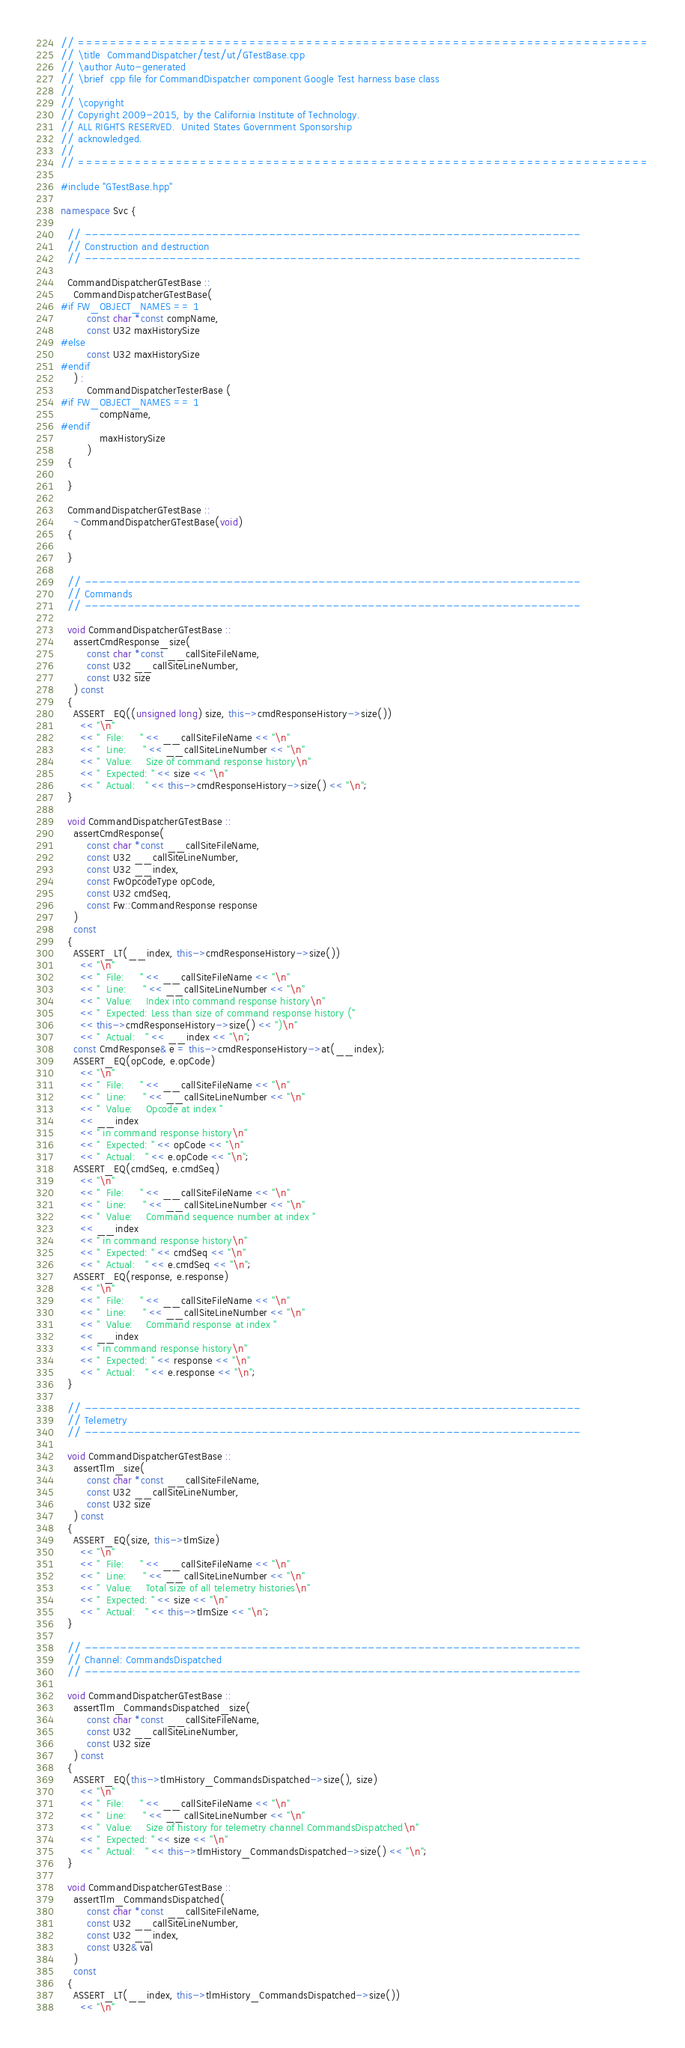<code> <loc_0><loc_0><loc_500><loc_500><_C++_>// ======================================================================
// \title  CommandDispatcher/test/ut/GTestBase.cpp
// \author Auto-generated
// \brief  cpp file for CommandDispatcher component Google Test harness base class
//
// \copyright
// Copyright 2009-2015, by the California Institute of Technology.
// ALL RIGHTS RESERVED.  United States Government Sponsorship
// acknowledged.
//
// ======================================================================

#include "GTestBase.hpp"

namespace Svc {

  // ----------------------------------------------------------------------
  // Construction and destruction
  // ----------------------------------------------------------------------

  CommandDispatcherGTestBase ::
    CommandDispatcherGTestBase(
#if FW_OBJECT_NAMES == 1
        const char *const compName,
        const U32 maxHistorySize
#else
        const U32 maxHistorySize
#endif
    ) :
        CommandDispatcherTesterBase (
#if FW_OBJECT_NAMES == 1
            compName,
#endif
            maxHistorySize
        )
  {

  }

  CommandDispatcherGTestBase ::
    ~CommandDispatcherGTestBase(void)
  {

  }

  // ----------------------------------------------------------------------
  // Commands
  // ----------------------------------------------------------------------

  void CommandDispatcherGTestBase ::
    assertCmdResponse_size(
        const char *const __callSiteFileName,
        const U32 __callSiteLineNumber,
        const U32 size
    ) const
  {
    ASSERT_EQ((unsigned long) size, this->cmdResponseHistory->size())
      << "\n"
      << "  File:     " << __callSiteFileName << "\n"
      << "  Line:     " << __callSiteLineNumber << "\n"
      << "  Value:    Size of command response history\n"
      << "  Expected: " << size << "\n"
      << "  Actual:   " << this->cmdResponseHistory->size() << "\n";
  }

  void CommandDispatcherGTestBase ::
    assertCmdResponse(
        const char *const __callSiteFileName,
        const U32 __callSiteLineNumber,
        const U32 __index,
        const FwOpcodeType opCode,
        const U32 cmdSeq,
        const Fw::CommandResponse response
    )
    const
  {
    ASSERT_LT(__index, this->cmdResponseHistory->size())
      << "\n"
      << "  File:     " << __callSiteFileName << "\n"
      << "  Line:     " << __callSiteLineNumber << "\n"
      << "  Value:    Index into command response history\n"
      << "  Expected: Less than size of command response history ("
      << this->cmdResponseHistory->size() << ")\n"
      << "  Actual:   " << __index << "\n";
    const CmdResponse& e = this->cmdResponseHistory->at(__index);
    ASSERT_EQ(opCode, e.opCode)
      << "\n"
      << "  File:     " << __callSiteFileName << "\n"
      << "  Line:     " << __callSiteLineNumber << "\n"
      << "  Value:    Opcode at index "
      << __index
      << " in command response history\n"
      << "  Expected: " << opCode << "\n"
      << "  Actual:   " << e.opCode << "\n";
    ASSERT_EQ(cmdSeq, e.cmdSeq)
      << "\n"
      << "  File:     " << __callSiteFileName << "\n"
      << "  Line:     " << __callSiteLineNumber << "\n"
      << "  Value:    Command sequence number at index "
      << __index
      << " in command response history\n"
      << "  Expected: " << cmdSeq << "\n"
      << "  Actual:   " << e.cmdSeq << "\n";
    ASSERT_EQ(response, e.response)
      << "\n"
      << "  File:     " << __callSiteFileName << "\n"
      << "  Line:     " << __callSiteLineNumber << "\n"
      << "  Value:    Command response at index "
      << __index
      << " in command response history\n"
      << "  Expected: " << response << "\n"
      << "  Actual:   " << e.response << "\n";
  }

  // ----------------------------------------------------------------------
  // Telemetry
  // ----------------------------------------------------------------------

  void CommandDispatcherGTestBase ::
    assertTlm_size(
        const char *const __callSiteFileName,
        const U32 __callSiteLineNumber,
        const U32 size
    ) const
  {
    ASSERT_EQ(size, this->tlmSize)
      << "\n"
      << "  File:     " << __callSiteFileName << "\n"
      << "  Line:     " << __callSiteLineNumber << "\n"
      << "  Value:    Total size of all telemetry histories\n"
      << "  Expected: " << size << "\n"
      << "  Actual:   " << this->tlmSize << "\n";
  }

  // ----------------------------------------------------------------------
  // Channel: CommandsDispatched
  // ----------------------------------------------------------------------

  void CommandDispatcherGTestBase ::
    assertTlm_CommandsDispatched_size(
        const char *const __callSiteFileName,
        const U32 __callSiteLineNumber,
        const U32 size
    ) const
  {
    ASSERT_EQ(this->tlmHistory_CommandsDispatched->size(), size)
      << "\n"
      << "  File:     " << __callSiteFileName << "\n"
      << "  Line:     " << __callSiteLineNumber << "\n"
      << "  Value:    Size of history for telemetry channel CommandsDispatched\n"
      << "  Expected: " << size << "\n"
      << "  Actual:   " << this->tlmHistory_CommandsDispatched->size() << "\n";
  }

  void CommandDispatcherGTestBase ::
    assertTlm_CommandsDispatched(
        const char *const __callSiteFileName,
        const U32 __callSiteLineNumber,
        const U32 __index,
        const U32& val
    )
    const
  {
    ASSERT_LT(__index, this->tlmHistory_CommandsDispatched->size())
      << "\n"</code> 